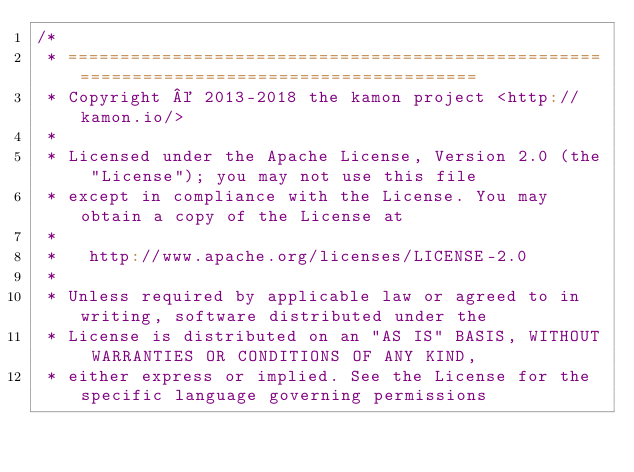<code> <loc_0><loc_0><loc_500><loc_500><_Scala_>/*
 * =========================================================================================
 * Copyright © 2013-2018 the kamon project <http://kamon.io/>
 *
 * Licensed under the Apache License, Version 2.0 (the "License"); you may not use this file
 * except in compliance with the License. You may obtain a copy of the License at
 *
 *   http://www.apache.org/licenses/LICENSE-2.0
 *
 * Unless required by applicable law or agreed to in writing, software distributed under the
 * License is distributed on an "AS IS" BASIS, WITHOUT WARRANTIES OR CONDITIONS OF ANY KIND,
 * either express or implied. See the License for the specific language governing permissions</code> 